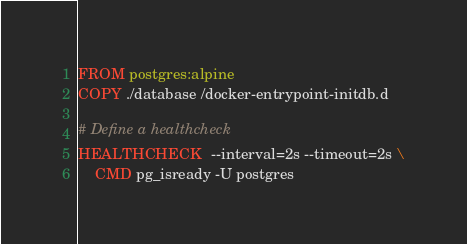<code> <loc_0><loc_0><loc_500><loc_500><_Dockerfile_>FROM postgres:alpine
COPY ./database /docker-entrypoint-initdb.d

# Define a healthcheck
HEALTHCHECK  --interval=2s --timeout=2s \
	CMD pg_isready -U postgres
</code> 